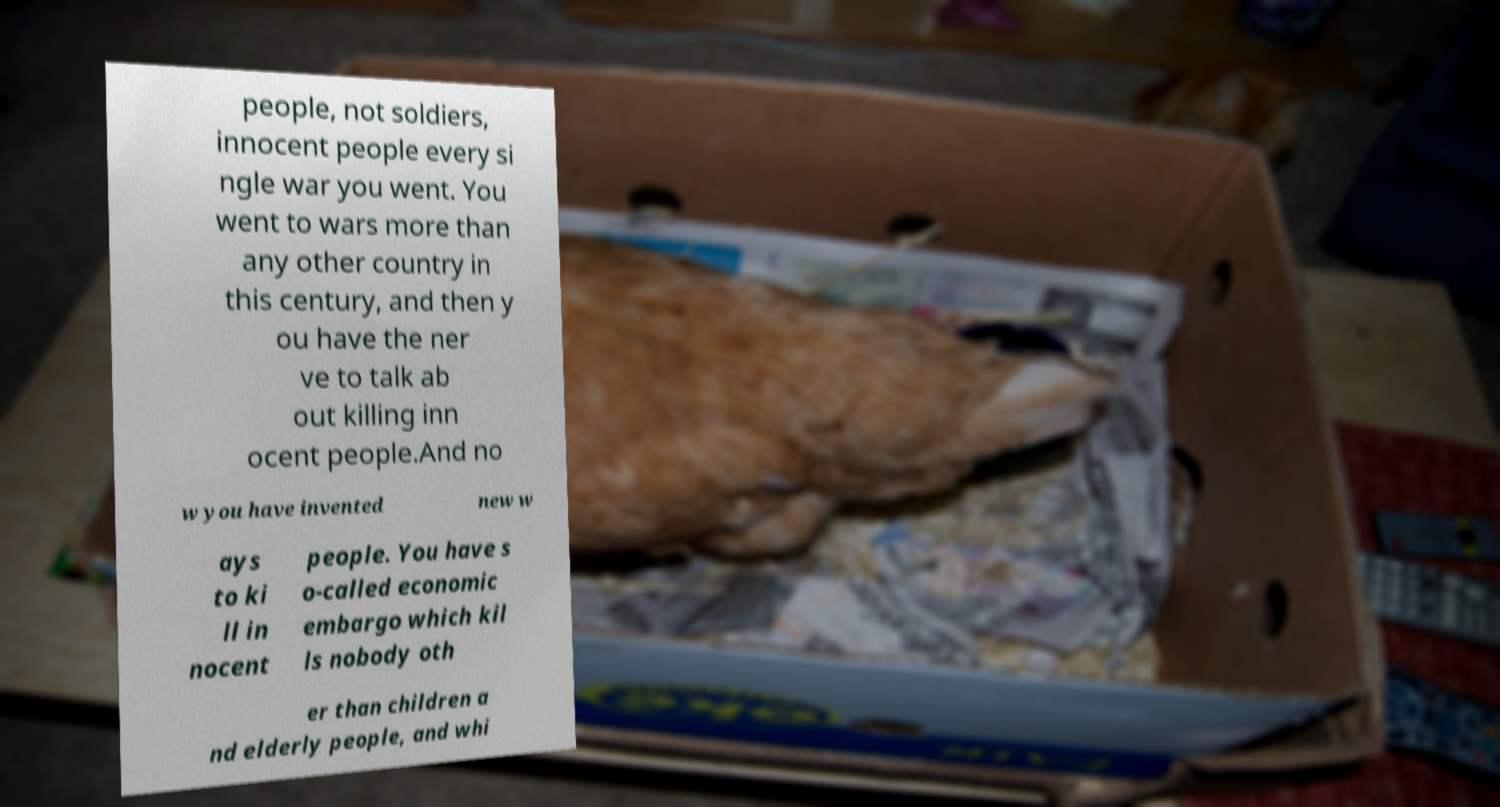There's text embedded in this image that I need extracted. Can you transcribe it verbatim? people, not soldiers, innocent people every si ngle war you went. You went to wars more than any other country in this century, and then y ou have the ner ve to talk ab out killing inn ocent people.And no w you have invented new w ays to ki ll in nocent people. You have s o-called economic embargo which kil ls nobody oth er than children a nd elderly people, and whi 